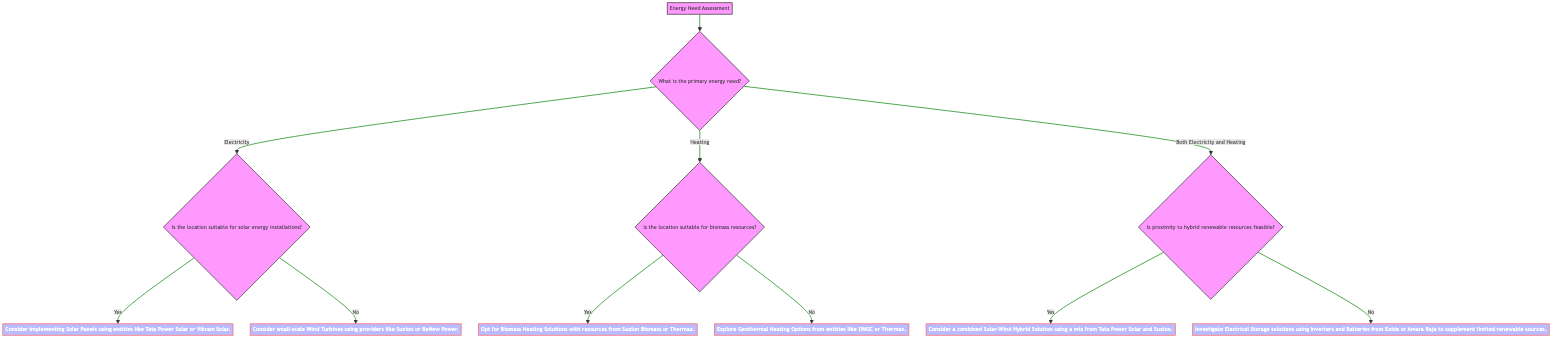What is the starting point of the Decision Tree? The starting point of the Decision Tree is labeled as "Energy Need Assessment." It serves as the initial node from which all further questions branch out.
Answer: Energy Need Assessment How many options are available for the primary energy need? The question regarding the primary energy need presents three options: Electricity, Heating, and Both Electricity and Heating. Thus, there are three options available at this node.
Answer: Three What decision is reached if the location is suitable for solar energy installations? If the location is deemed suitable for solar energy installations (the answer to the question at node 2 is "Yes"), the decision made is to "Consider implementing Solar Panels using entities like Tata Power Solar or Vikram Solar."
Answer: Consider implementing Solar Panels using entities like Tata Power Solar or Vikram Solar What is the outcome if the primary energy need is both electricity and heating, and proximity to hybrid renewable resources is not feasible? If both electricity and heating are needed and the proximity to hybrid renewable resources is not feasible, then the outcome is to "Investigate Electrical Storage solutions using Inverters and Batteries from Exide or Amara Raja to supplement limited renewable sources."
Answer: Investigate Electrical Storage solutions using Inverters and Batteries from Exide or Amara Raja to supplement limited renewable sources What happens if the location is suitable for biomass resources? If the location is suitable for biomass resources (the answer to the question at node 3 is "Yes"), the action taken will be to "Opt for Biomass Heating Solutions with resources from Suzlon Biomass or Thermax."
Answer: Opt for Biomass Heating Solutions with resources from Suzlon Biomass or Thermax What is the decision made when the primary energy need is heating and the location is not suitable for biomass resources? When the primary energy need is heating and the location is not suitable for biomass resources (the answer to the question at node 3 is "No"), the decision flows to explore geothermal options. The outcome is to "Explore Geothermal Heating Options from entities like ONGC or Thermax."
Answer: Explore Geothermal Heating Options from entities like ONGC or Thermax 